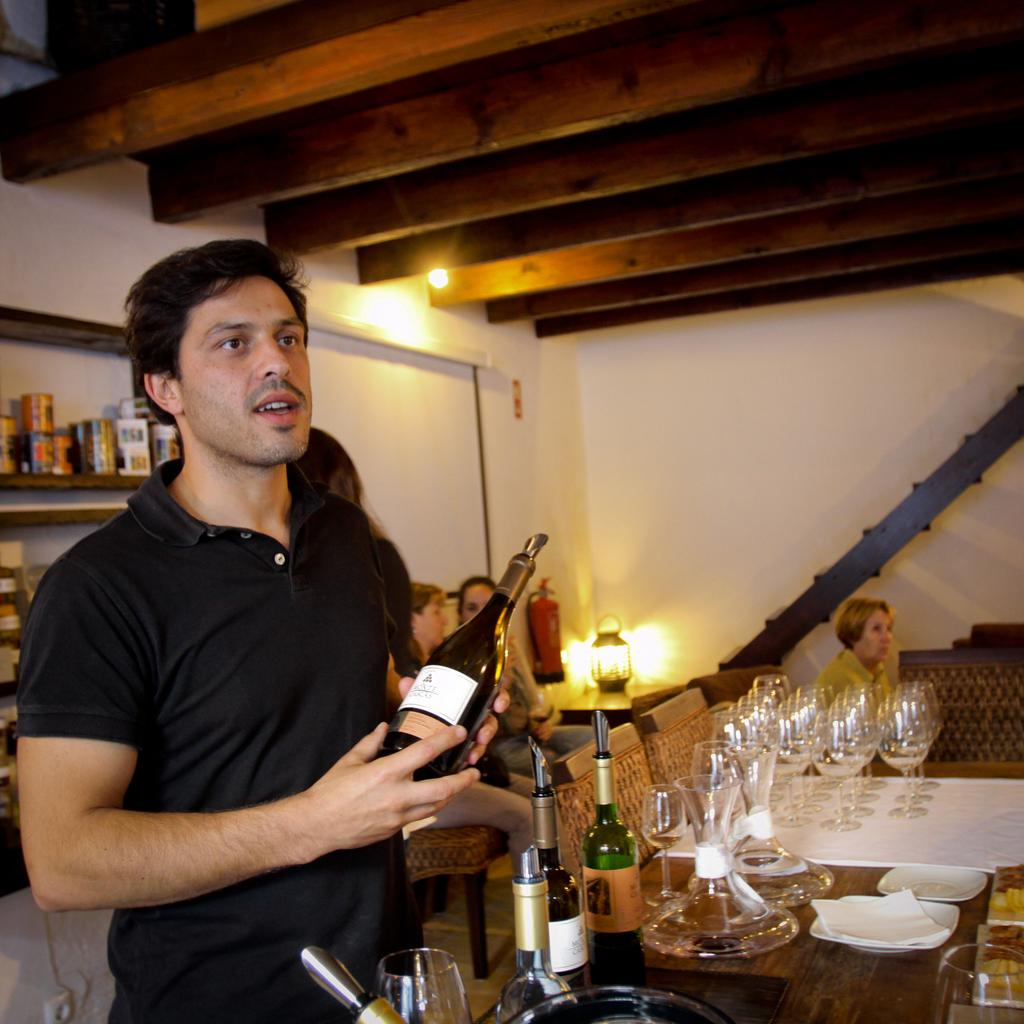Who is present in the image? There is a man in the image. What is the man holding in his hand? The man is holding a glass bottle in his hand. What piece of furniture can be seen in the image? There is a table in the image. What type of objects are on the table? There are glasses on the table. Can you describe any other objects on the table? There are other objects on the table, but their specific details are not mentioned in the provided facts. What type of brush is the man using to add more paint to the canvas in the image? There is no canvas, paint, or brush present in the image. The man is holding a glass bottle, and there is a table with glasses and other objects on it. 